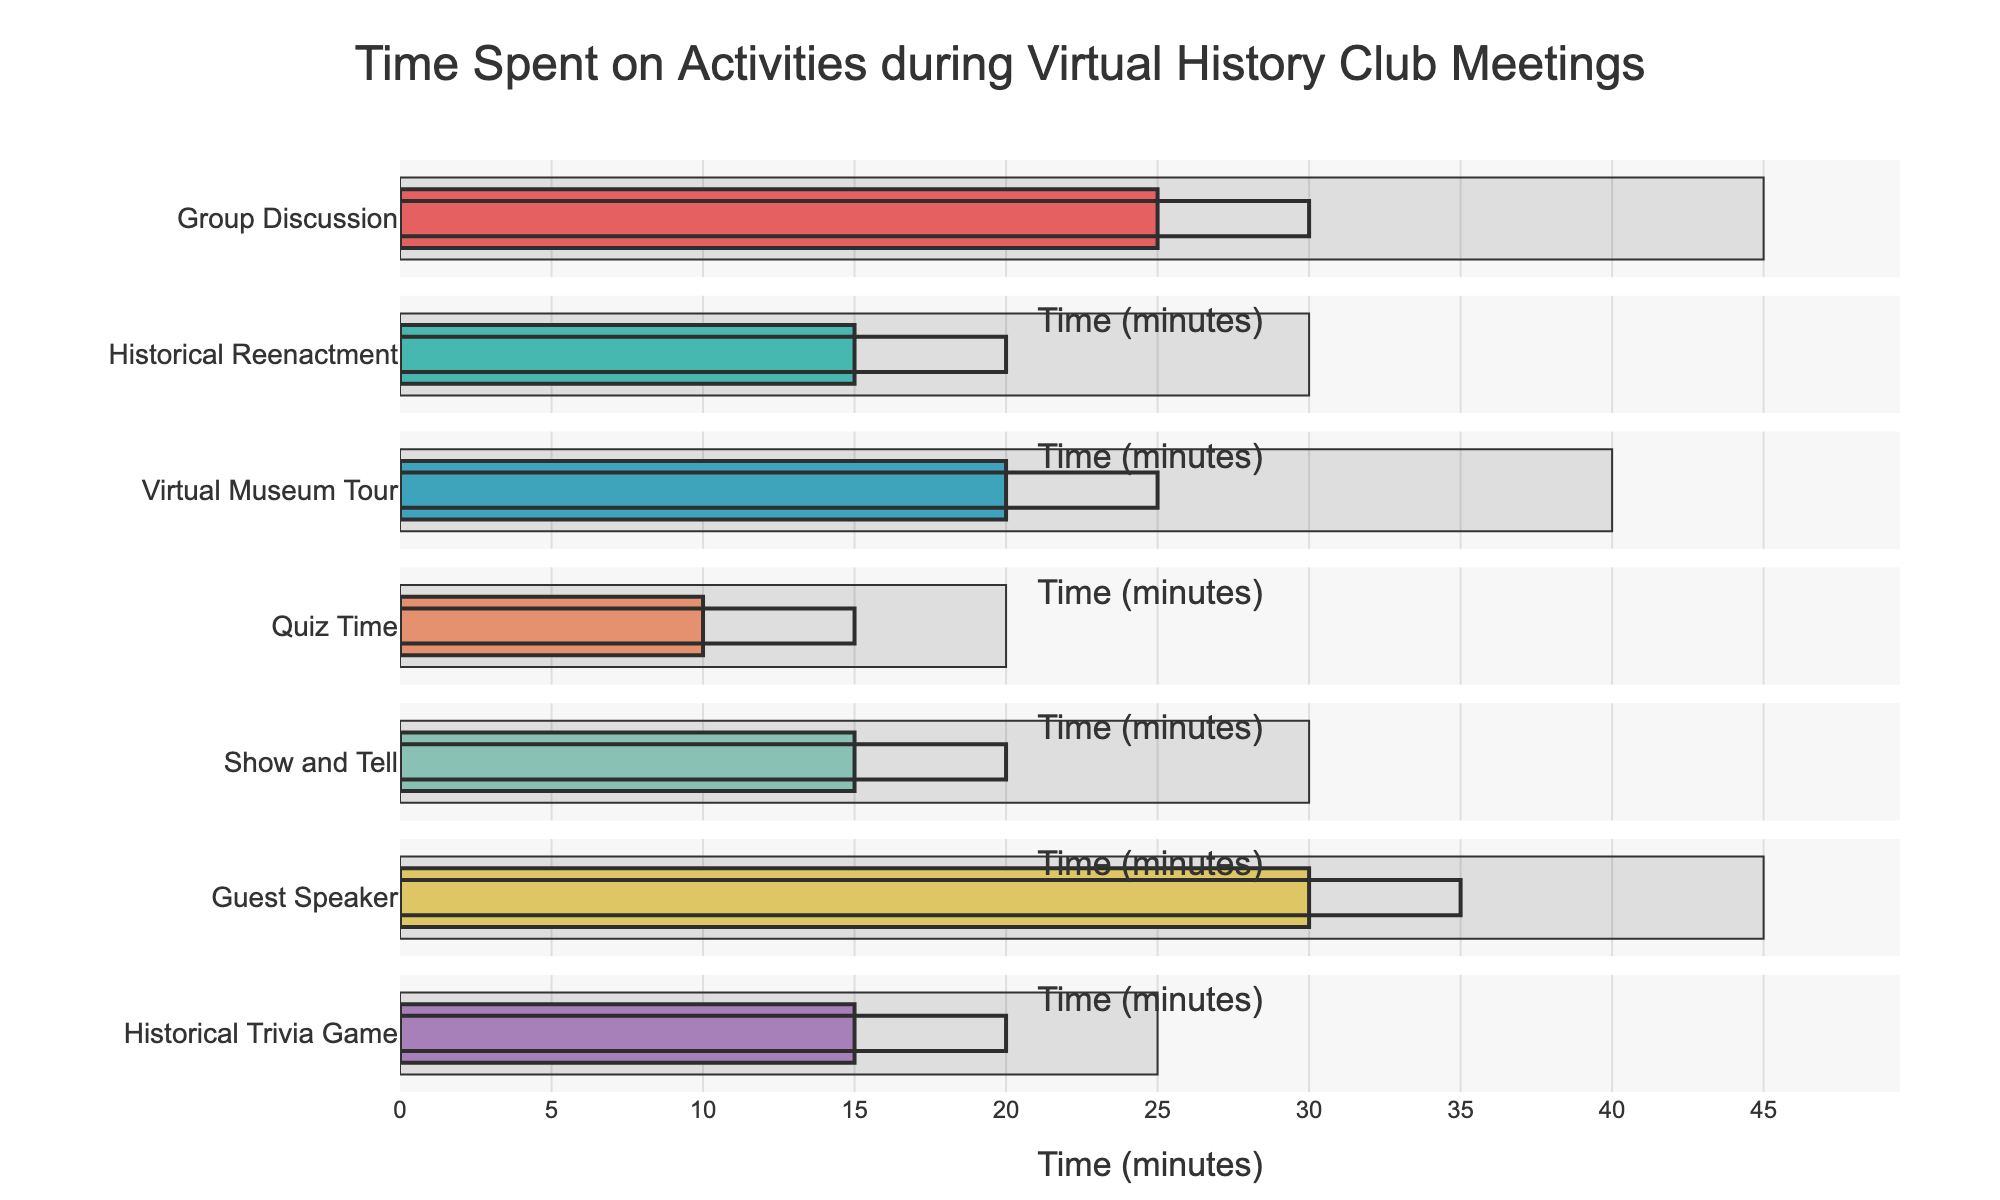What is the title of the chart? The title is located at the top-center of the figure and is the most prominent text element.
Answer: Time Spent on Activities during Virtual History Club Meetings How much time was actually spent on Historical Reenactment? Locate the bar corresponding to Historical Reenactment in the figure. The length of the "Actual" bar is 15 minutes.
Answer: 15 minutes What is the target time for Group Discussion? Find the Group Discussion bar and check the "Target" bar. It is 30 minutes.
Answer: 30 minutes Which activity has the highest maximum time? Identify all maximum bars and compare their lengths. The Guest Speaker activity has the longest maximum bar at 45 minutes.
Answer: Guest Speaker What is the difference between the target and actual time for Show and Tell? Subtract the actual time (15 minutes) from the target time (20 minutes) for Show and Tell.
Answer: 5 minutes What is the total maximum time for all activities? Sum the maximum times for all activities: 45 + 30 + 40 + 20 + 30 + 45 + 25 = 235 minutes.
Answer: 235 minutes Which activity had more actual time, Quiz Time or Historical Trivia Game? Compare the actual bars for Quiz Time (10 minutes) and Historical Trivia Game (15 minutes). Historical Trivia Game has more actual time.
Answer: Historical Trivia Game Are there any activities where the actual time met or exceeded the target time? If yes, which ones? Compare all actual and target bars. No actual time meets or exceeds the target time in any activity.
Answer: No What is the average target time across all activities? Sum all target times and divide by the number of activities: (30 + 20 + 25 + 15 + 20 + 35 + 20) / 7 = 165 / 7 = approx. 23.57 minutes.
Answer: approx. 23.57 minutes 